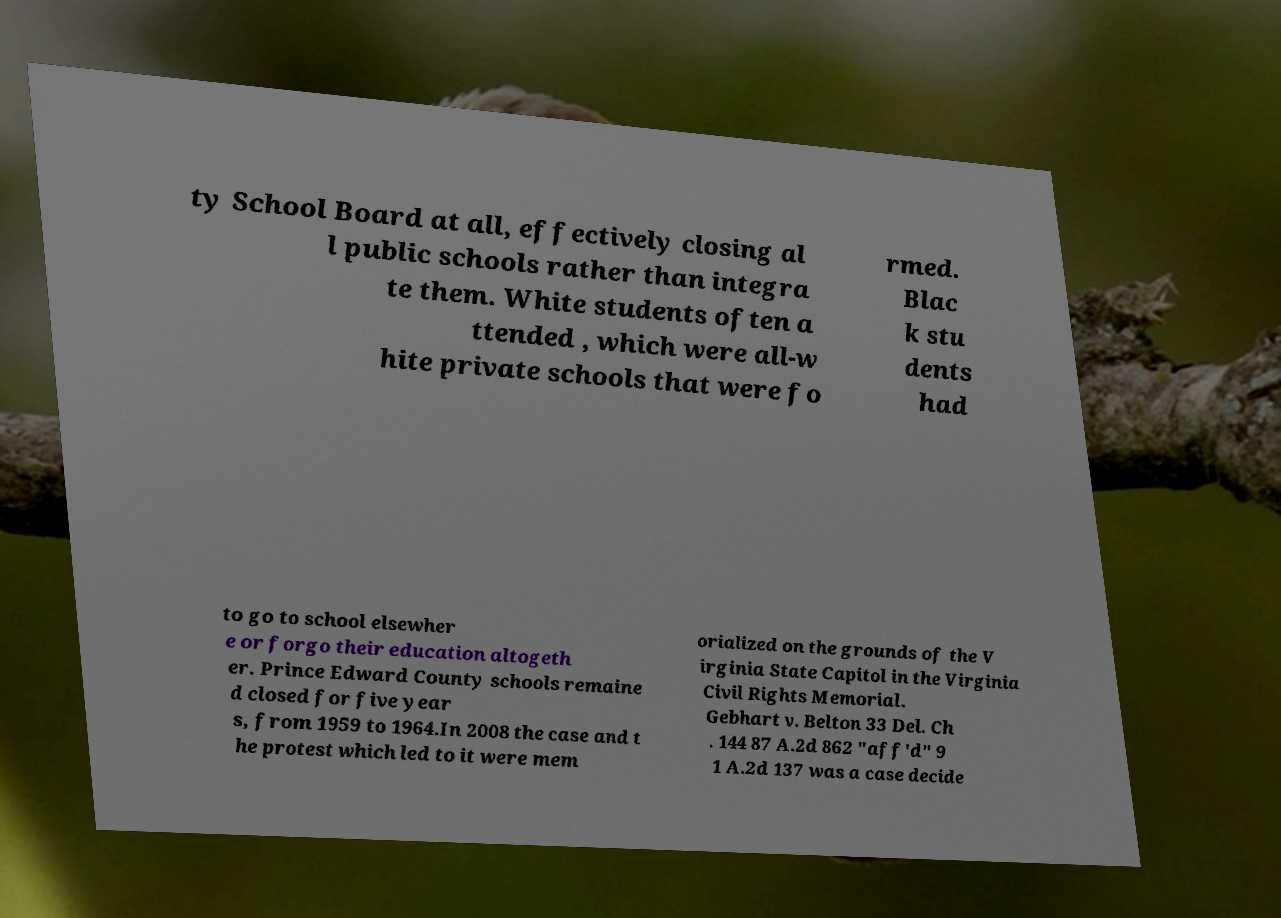Can you accurately transcribe the text from the provided image for me? ty School Board at all, effectively closing al l public schools rather than integra te them. White students often a ttended , which were all-w hite private schools that were fo rmed. Blac k stu dents had to go to school elsewher e or forgo their education altogeth er. Prince Edward County schools remaine d closed for five year s, from 1959 to 1964.In 2008 the case and t he protest which led to it were mem orialized on the grounds of the V irginia State Capitol in the Virginia Civil Rights Memorial. Gebhart v. Belton 33 Del. Ch . 144 87 A.2d 862 "aff'd" 9 1 A.2d 137 was a case decide 